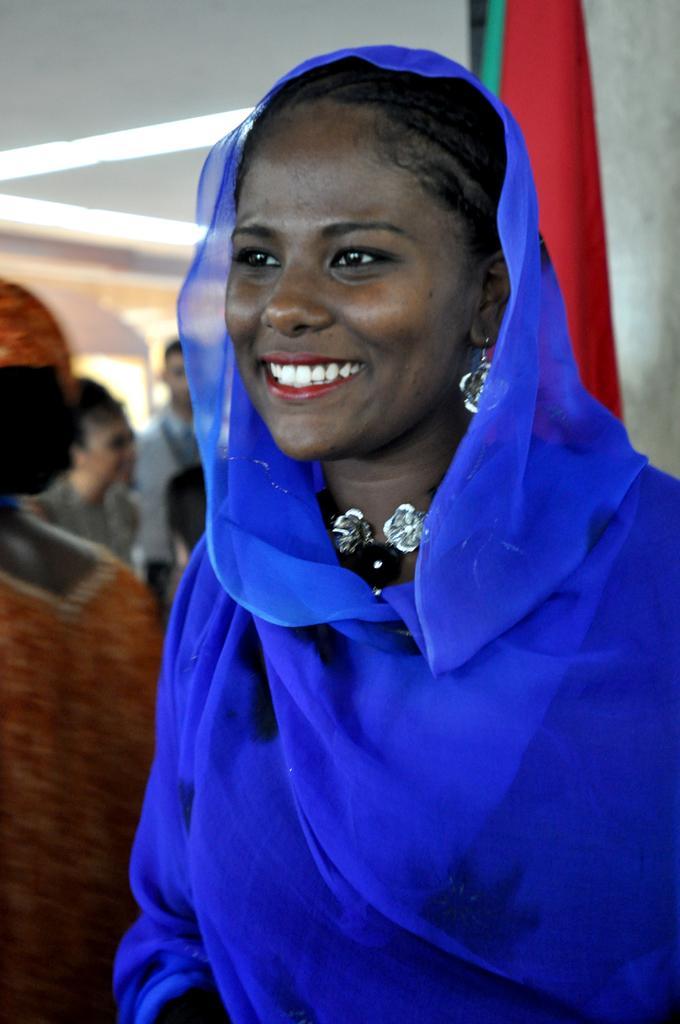Could you give a brief overview of what you see in this image? Here I can see a woman wearing a blue color scarf, facing to the left side and smiling. In the background, I can see some more people. At the back of the woman I can see a red color cloth. In the background, I can see the wall. 